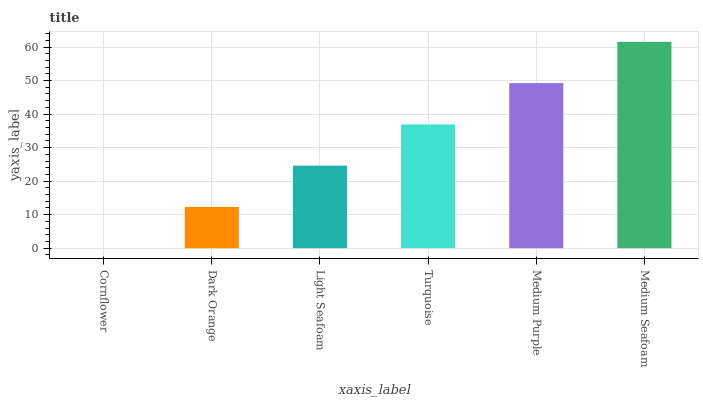Is Dark Orange the minimum?
Answer yes or no. No. Is Dark Orange the maximum?
Answer yes or no. No. Is Dark Orange greater than Cornflower?
Answer yes or no. Yes. Is Cornflower less than Dark Orange?
Answer yes or no. Yes. Is Cornflower greater than Dark Orange?
Answer yes or no. No. Is Dark Orange less than Cornflower?
Answer yes or no. No. Is Turquoise the high median?
Answer yes or no. Yes. Is Light Seafoam the low median?
Answer yes or no. Yes. Is Cornflower the high median?
Answer yes or no. No. Is Medium Seafoam the low median?
Answer yes or no. No. 